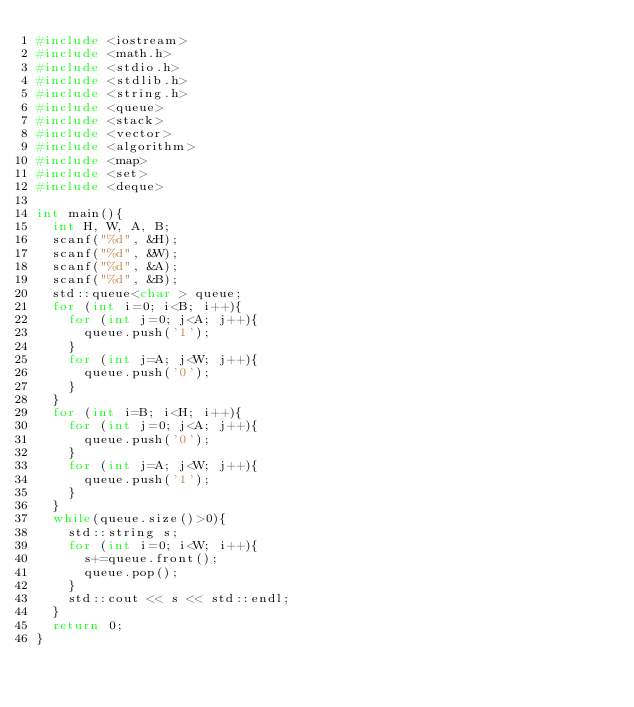Convert code to text. <code><loc_0><loc_0><loc_500><loc_500><_C++_>#include <iostream>
#include <math.h>
#include <stdio.h>
#include <stdlib.h>
#include <string.h>
#include <queue>
#include <stack>
#include <vector>
#include <algorithm>
#include <map>
#include <set>
#include <deque>

int main(){
  int H, W, A, B;
  scanf("%d", &H);
  scanf("%d", &W);
  scanf("%d", &A);
  scanf("%d", &B);
  std::queue<char > queue;
  for (int i=0; i<B; i++){
    for (int j=0; j<A; j++){
      queue.push('1');
    }
    for (int j=A; j<W; j++){
      queue.push('0');
    }
  }
  for (int i=B; i<H; i++){
    for (int j=0; j<A; j++){
      queue.push('0');
    }
    for (int j=A; j<W; j++){
      queue.push('1');
    }    
  }
  while(queue.size()>0){
    std::string s;
    for (int i=0; i<W; i++){
      s+=queue.front();
      queue.pop();
    }
    std::cout << s << std::endl;
  }
  return 0;
}
</code> 